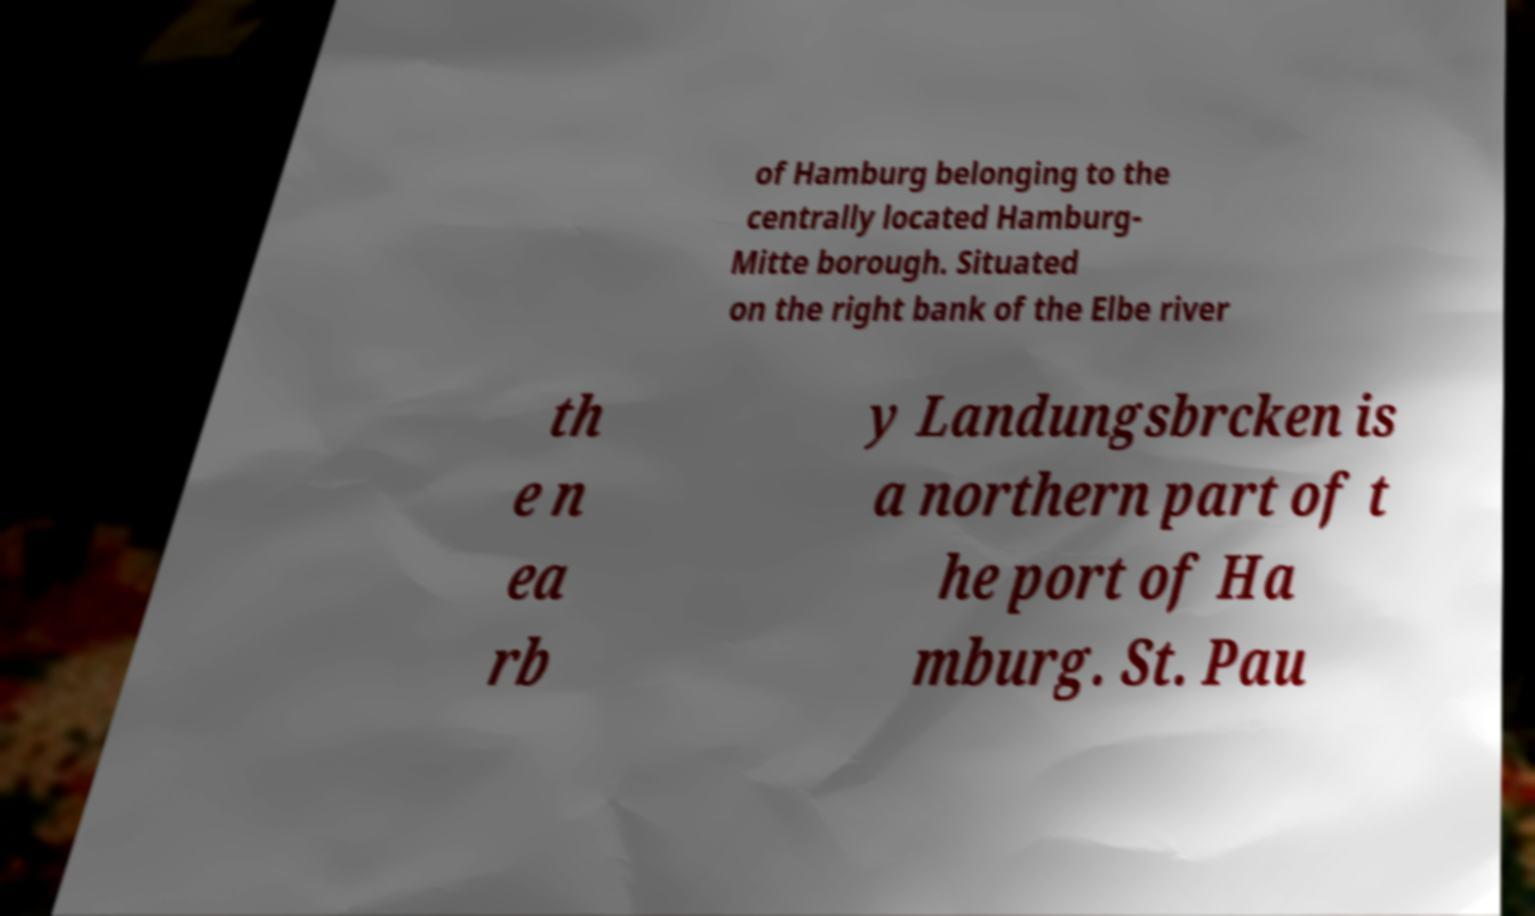For documentation purposes, I need the text within this image transcribed. Could you provide that? of Hamburg belonging to the centrally located Hamburg- Mitte borough. Situated on the right bank of the Elbe river th e n ea rb y Landungsbrcken is a northern part of t he port of Ha mburg. St. Pau 